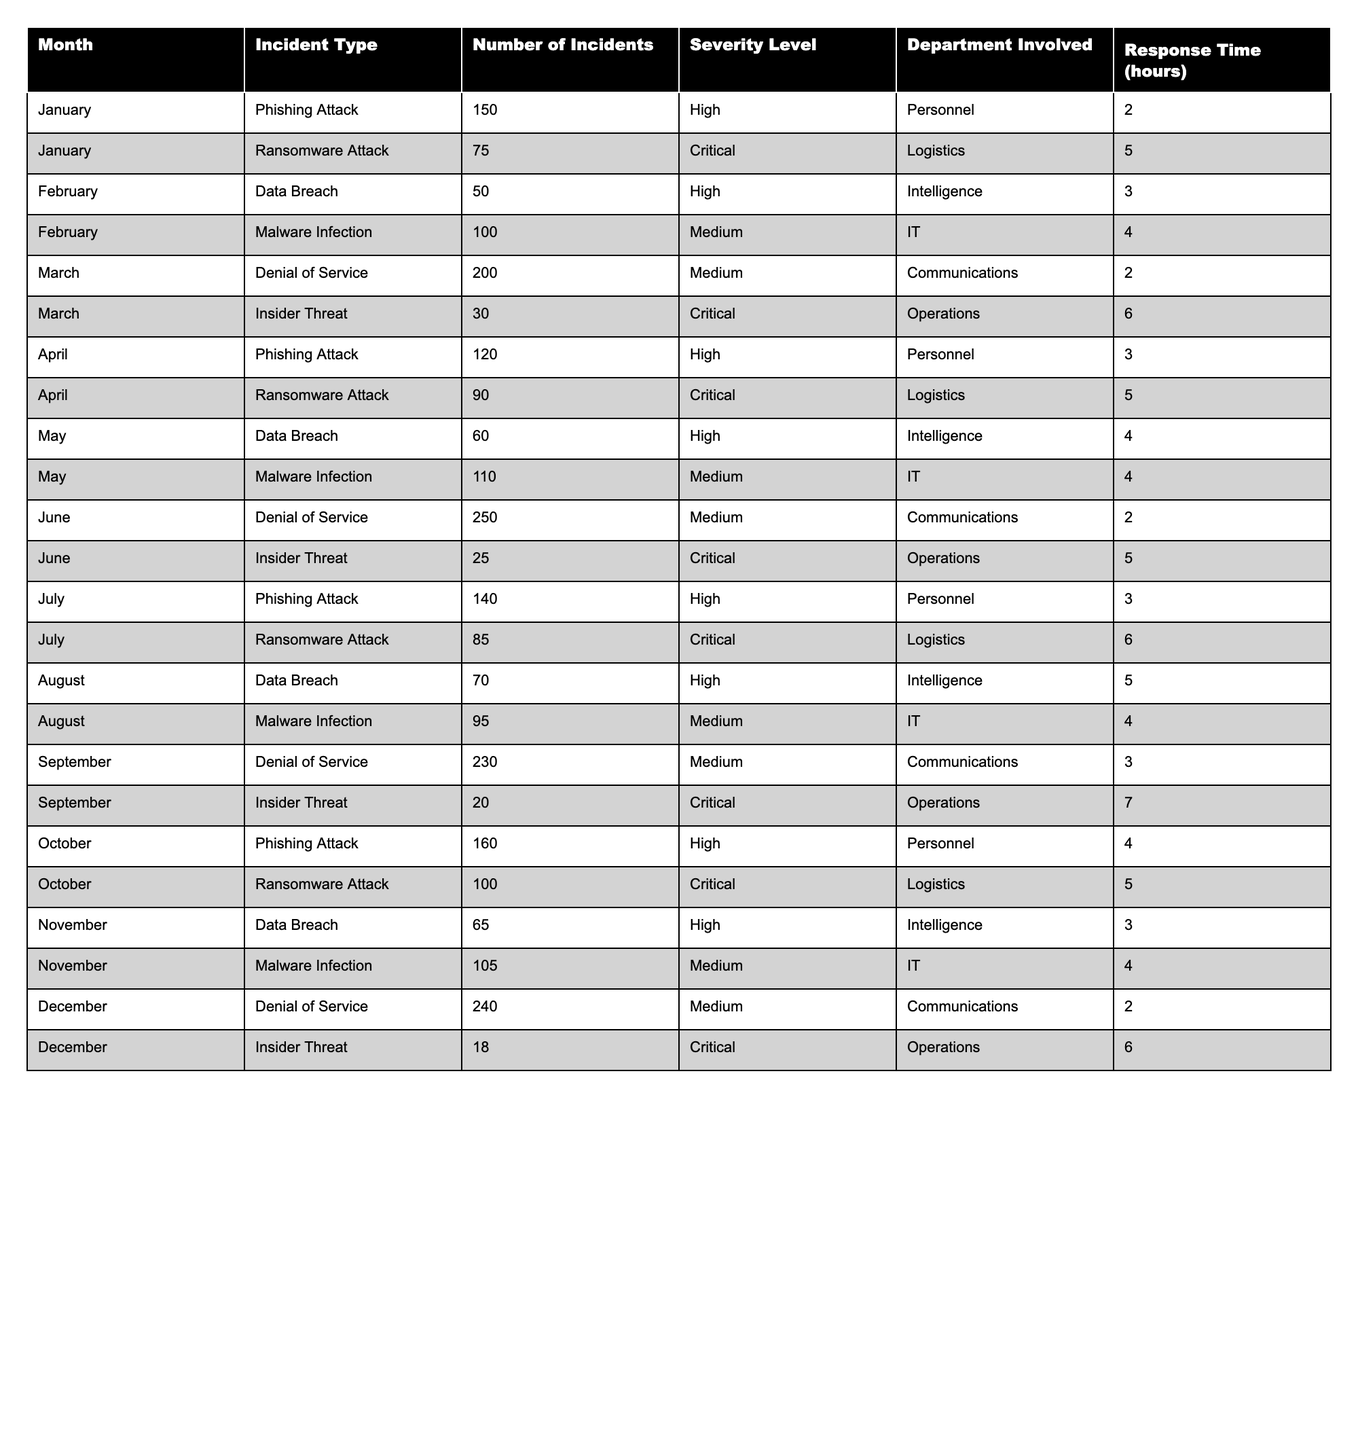What is the total number of incidents reported in June? In June, the total number of incidents is calculated by adding the two incident types: Denial of Service (250) and Insider Threat (25). Thus, 250 + 25 = 275.
Answer: 275 Which month had the highest number of Ransomware Attacks? Reviewing the incidents involving Ransomware Attacks across all months reveals January (75), April (90), July (85), and October (100). October had the highest with 100.
Answer: October What is the severity level of the highest number of incidents reported in March? In March, Denial of Service incidents numbered 200 and have a Medium severity level. The next highest number of incidents is the Insider Threat with 30 and Critical severity. Since 200 is the highest, its severity is Medium.
Answer: Medium How many incidents were reported in the first half of the year (January to June)? The incidents in the first half include: January (225), February (150), March (230), April (210), May (170), and June (275). Adding these gives 225 + 150 + 230 + 210 + 170 + 275 = 1260.
Answer: 1260 Which type of incident had the lowest response time on average? The response times for each incident type across the months can be averaged. Phishing Attacks (average 2.75), Ransomware Attacks (average 5.25), Data Breaches (average 4), Malware Infections (average 4), Denial of Service (average 2.5), and Insider Threats (average 5). The lowest average response time is for Denial of Service at 2.5 hours.
Answer: Denial of Service Did the number of Denial of Service incidents increase from February to December? In February, there were no Denial of Service incidents reported. The only recorded months for Denial of Service incidents are March (200), June (250), September (230), and December (240). Since there were no incidents in February, the answer is yes, it increased significantly to a high in June.
Answer: Yes What percentage of total incidents were Phishing Attacks in July? In July, there were 140 Phishing Attacks out of a total of 225 incidents (140 from Phishing, 85 from Ransomware). The percentage is calculated as (140/225)*100 = 62.22%.
Answer: 62.22% Which month involved the highest severity level incident type? Ransomware Attacks were classified as Critical severity. Observing the reported months, the highest number was in January (75) but the overall highest incident counts among Critical severity were reported in April (90) and July (85). Thus, April holds the record for the highest number of Critical severity incidents.
Answer: April 